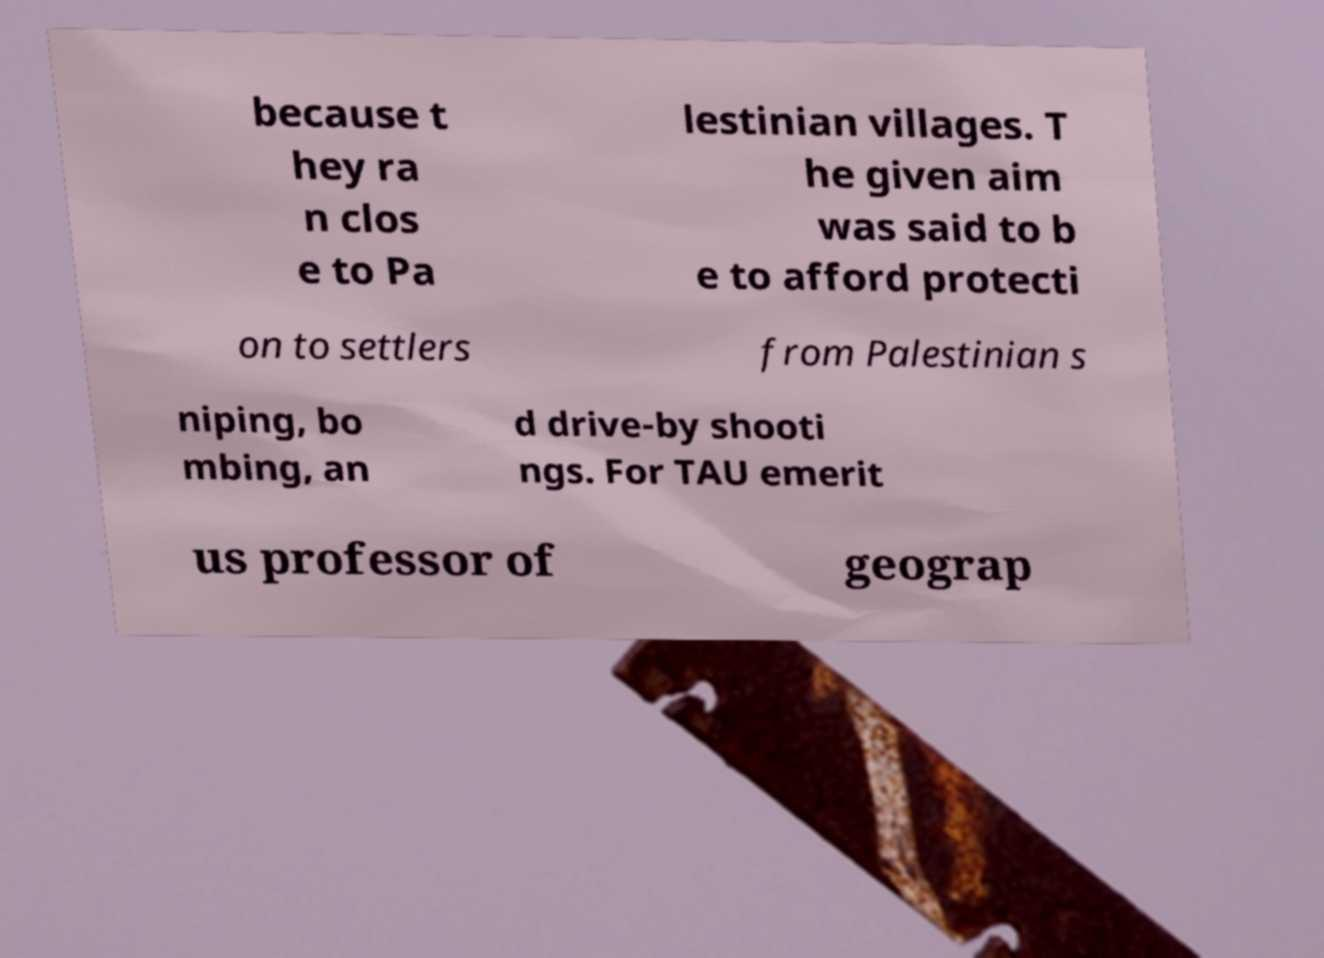What messages or text are displayed in this image? I need them in a readable, typed format. because t hey ra n clos e to Pa lestinian villages. T he given aim was said to b e to afford protecti on to settlers from Palestinian s niping, bo mbing, an d drive-by shooti ngs. For TAU emerit us professor of geograp 